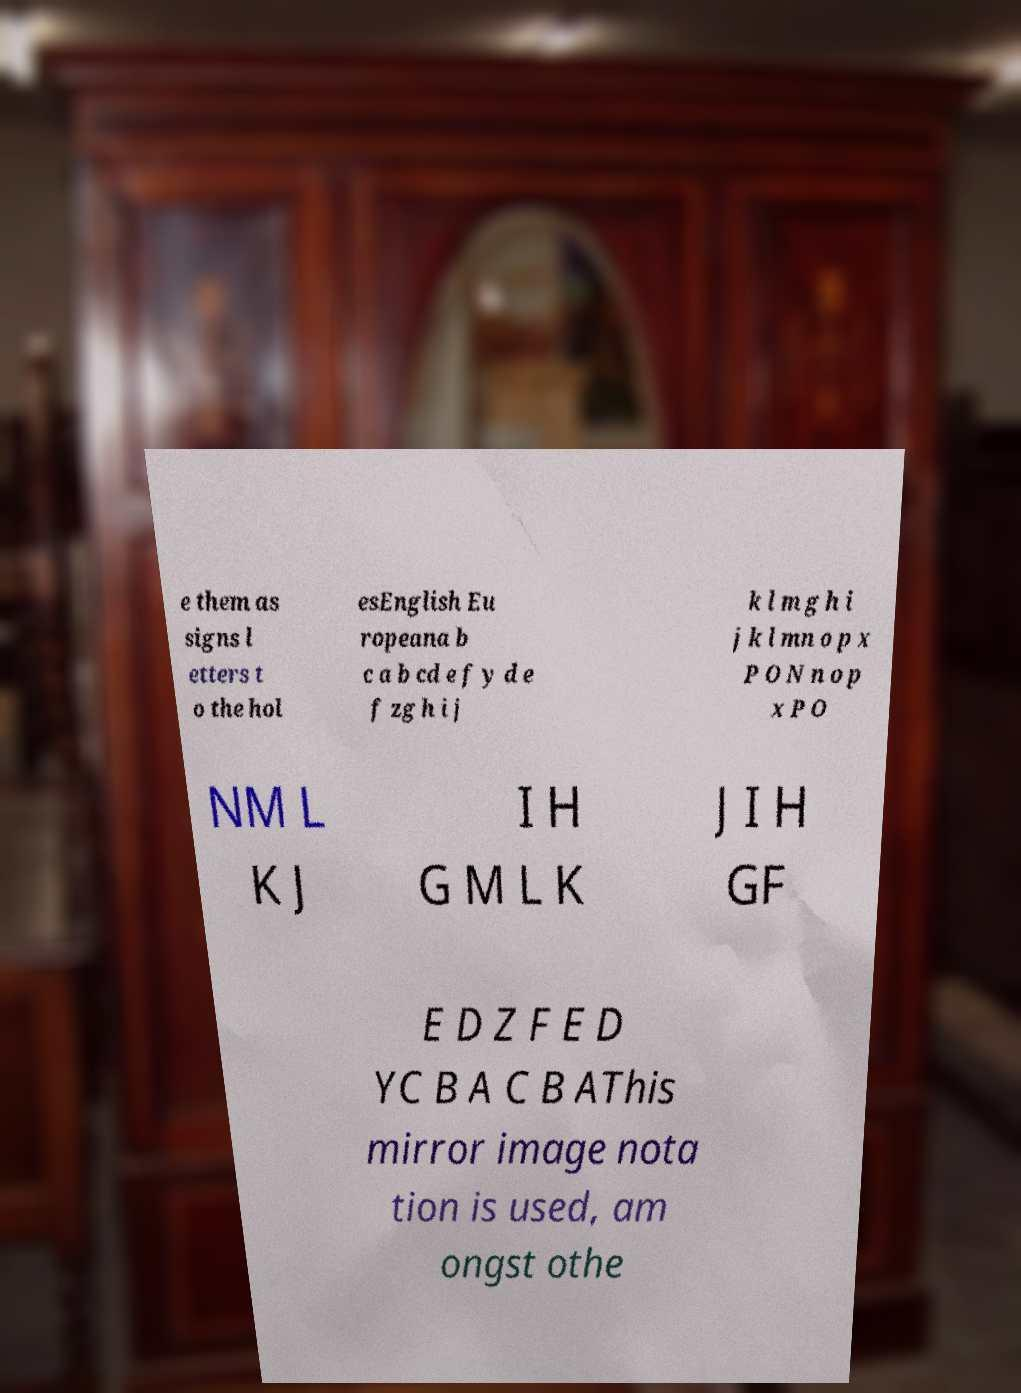For documentation purposes, I need the text within this image transcribed. Could you provide that? e them as signs l etters t o the hol esEnglish Eu ropeana b c a b cd e f y d e f zg h i j k l m g h i j k l mn o p x P O N n o p x P O NM L K J I H G M L K J I H GF E D Z F E D YC B A C B AThis mirror image nota tion is used, am ongst othe 